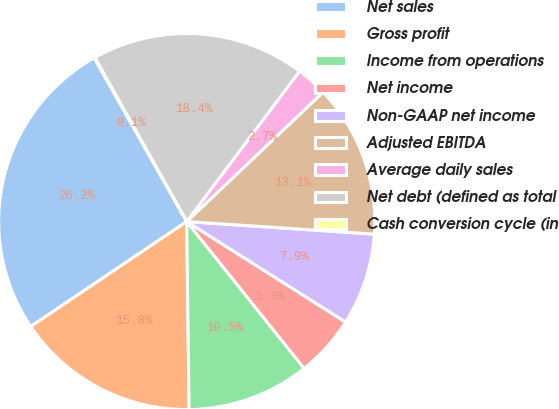<chart> <loc_0><loc_0><loc_500><loc_500><pie_chart><fcel>Net sales<fcel>Gross profit<fcel>Income from operations<fcel>Net income<fcel>Non-GAAP net income<fcel>Adjusted EBITDA<fcel>Average daily sales<fcel>Net debt (defined as total<fcel>Cash conversion cycle (in<nl><fcel>26.24%<fcel>15.77%<fcel>10.53%<fcel>5.29%<fcel>7.91%<fcel>13.15%<fcel>2.67%<fcel>18.38%<fcel>0.06%<nl></chart> 